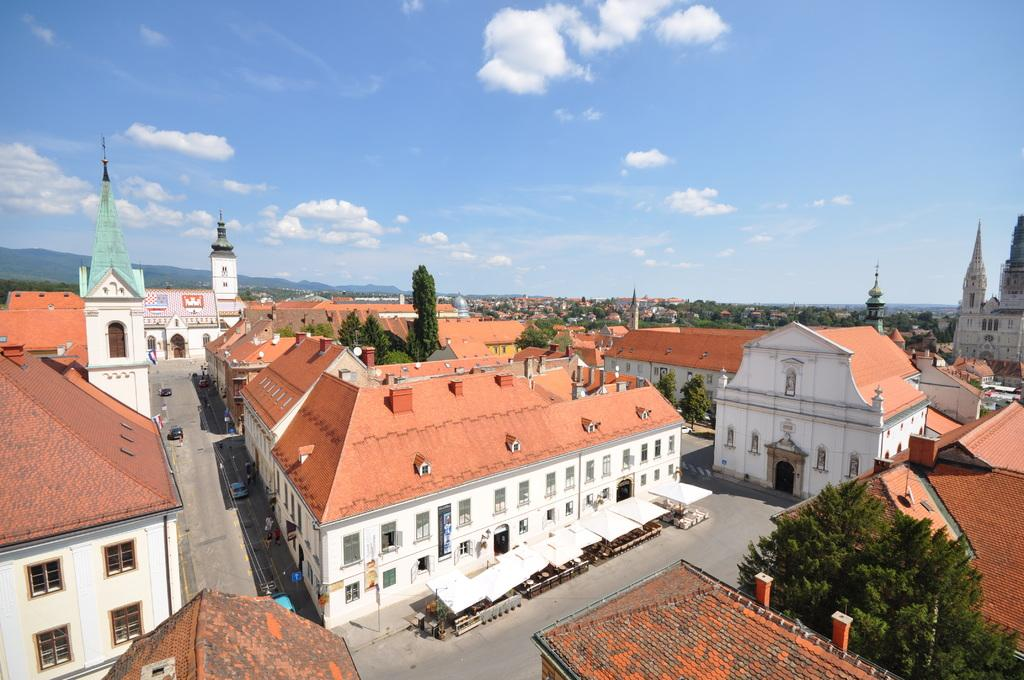What type of structures can be seen in the image? There are buildings in the image. What other natural elements are present in the image? There are trees in the image. What type of man-made objects can be seen in the image? There are vehicles and a pole in the image. What type of surface can be seen in the image? There are roads in the image. What additional man-made objects can be seen in the image? There is a board and flags in the image. What can be seen in the background of the image? The sky is visible in the background of the image. What type of arch can be seen in the image? There is no arch present in the image. Is there an island visible in the image? There is no island present in the image. 